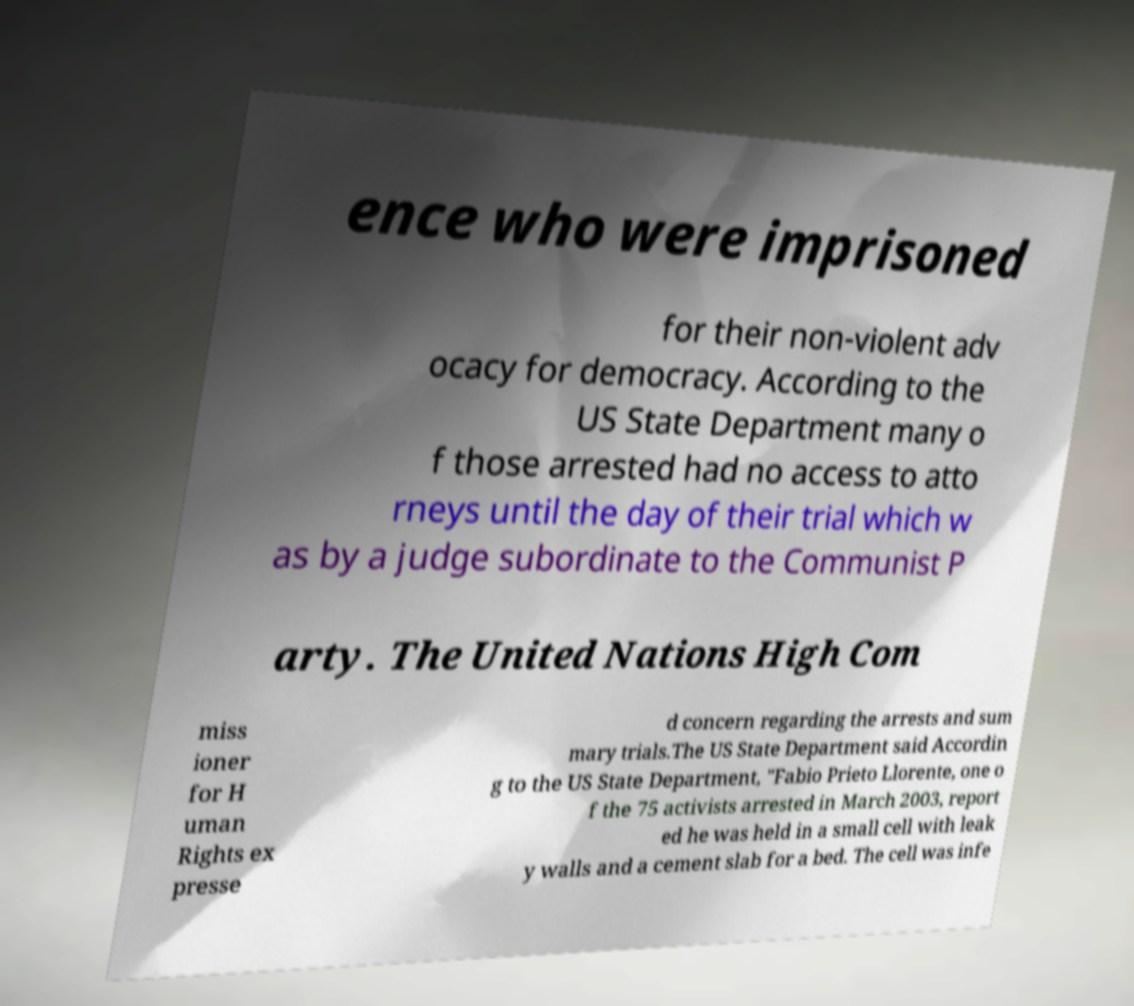Please read and relay the text visible in this image. What does it say? ence who were imprisoned for their non-violent adv ocacy for democracy. According to the US State Department many o f those arrested had no access to atto rneys until the day of their trial which w as by a judge subordinate to the Communist P arty. The United Nations High Com miss ioner for H uman Rights ex presse d concern regarding the arrests and sum mary trials.The US State Department said Accordin g to the US State Department, "Fabio Prieto Llorente, one o f the 75 activists arrested in March 2003, report ed he was held in a small cell with leak y walls and a cement slab for a bed. The cell was infe 